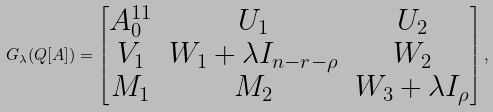Convert formula to latex. <formula><loc_0><loc_0><loc_500><loc_500>G _ { \lambda } ( Q [ A ] ) = \begin{bmatrix} A _ { 0 } ^ { 1 1 } & U _ { 1 } & U _ { 2 } \\ V _ { 1 } & W _ { 1 } + \lambda I _ { n - r - \rho } & W _ { 2 } \\ M _ { 1 } & M _ { 2 } & W _ { 3 } + \lambda I _ { \rho } \end{bmatrix} ,</formula> 